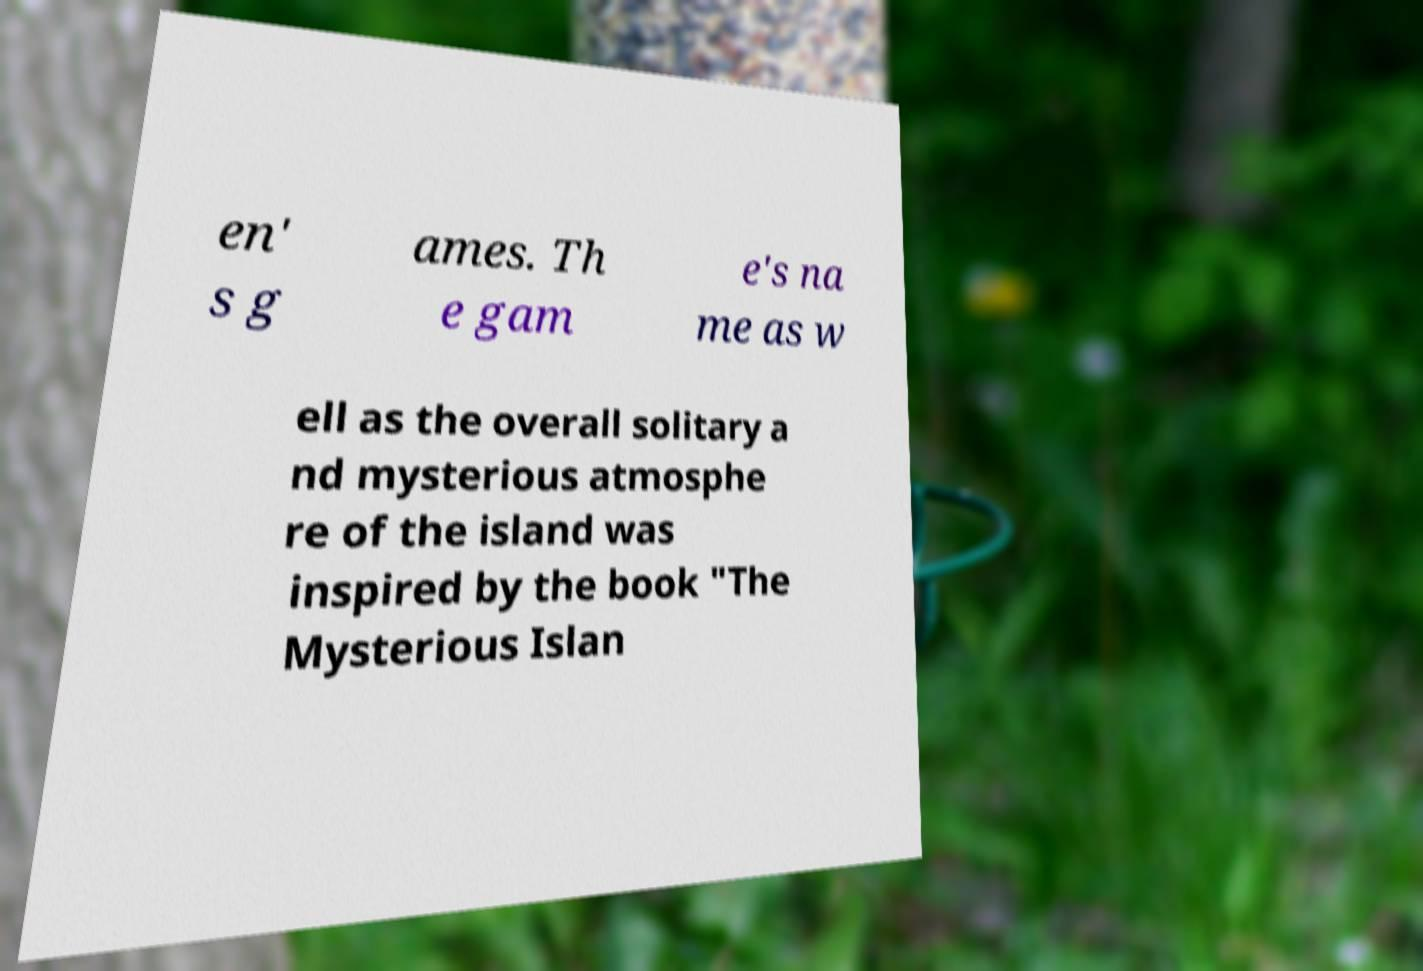Please identify and transcribe the text found in this image. en' s g ames. Th e gam e's na me as w ell as the overall solitary a nd mysterious atmosphe re of the island was inspired by the book "The Mysterious Islan 